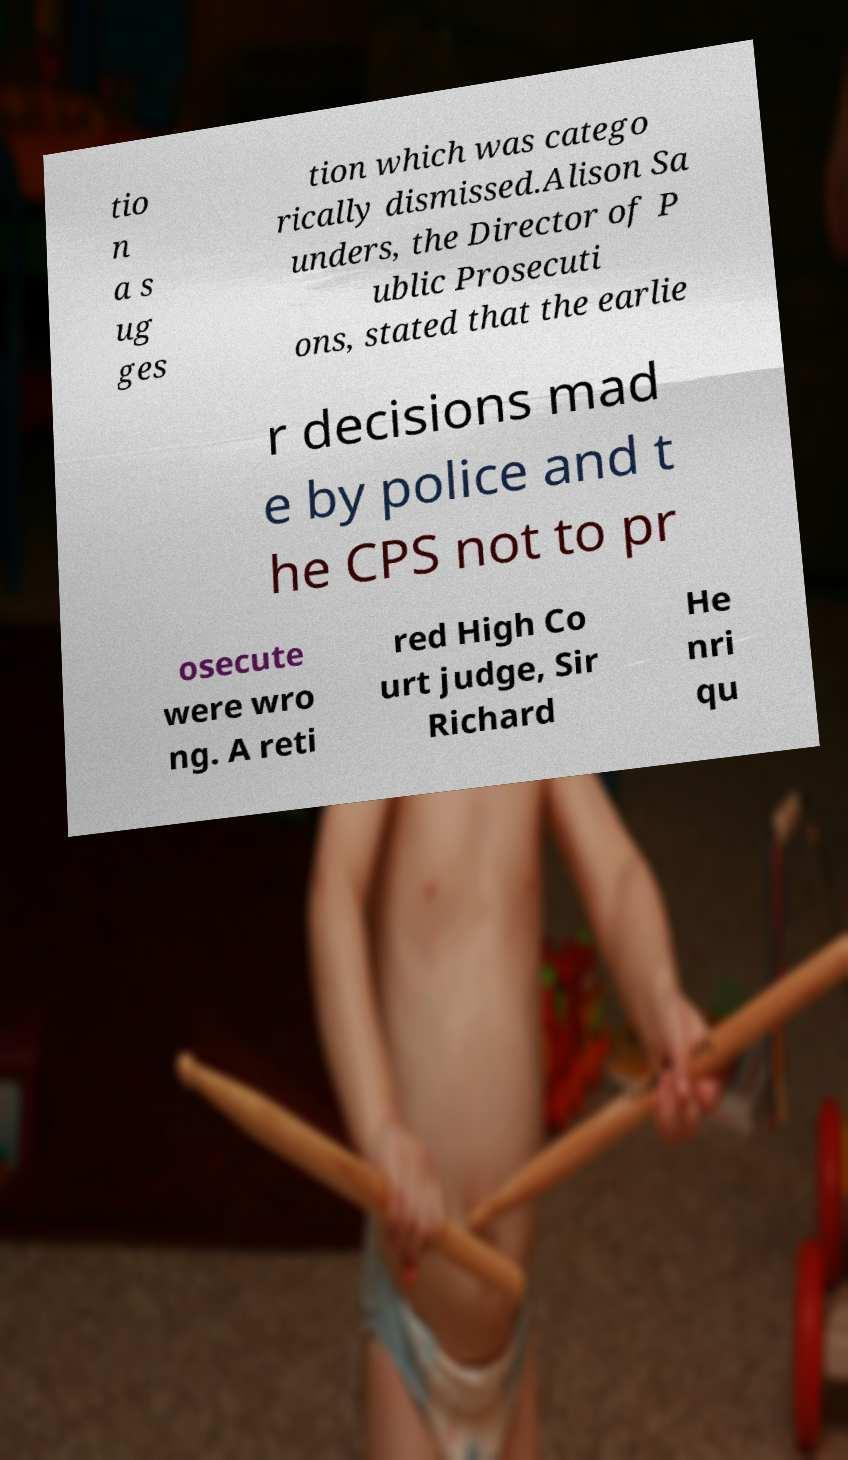Can you accurately transcribe the text from the provided image for me? tio n a s ug ges tion which was catego rically dismissed.Alison Sa unders, the Director of P ublic Prosecuti ons, stated that the earlie r decisions mad e by police and t he CPS not to pr osecute were wro ng. A reti red High Co urt judge, Sir Richard He nri qu 